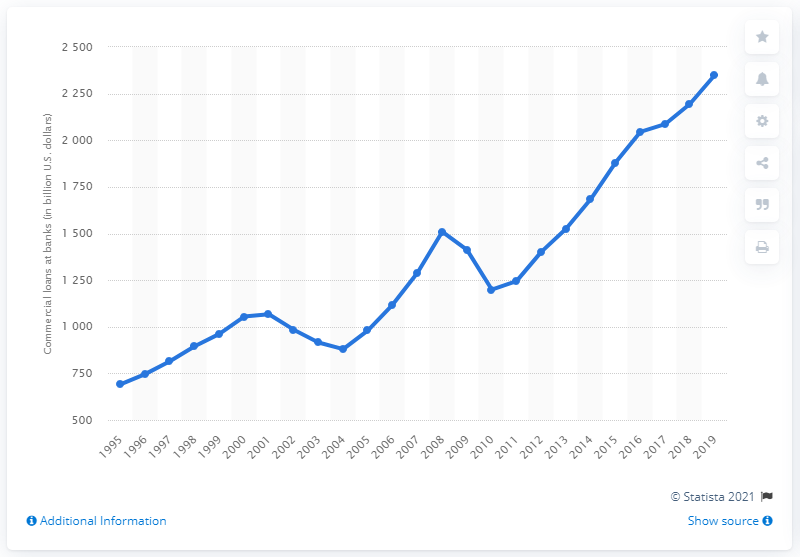Draw attention to some important aspects in this diagram. In 2019, the total value of commercial loans held by U.S. banks was approximately $2348.53 billion. In 1995, the total value of commercial and industrial loans at commercial banks in the United States was first reported. 